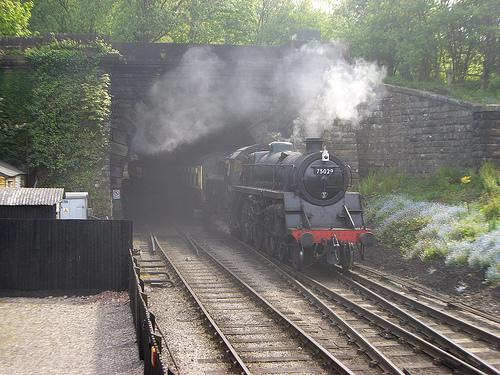Question: who is there?
Choices:
A. Everyone.
B. No one.
C. The father.
D. The family.
Answer with the letter. Answer: B Question: when was this?
Choices:
A. Nighttime.
B. Morning.
C. Daytime.
D. Dusk.
Answer with the letter. Answer: C Question: where is this scene?
Choices:
A. Bridge.
B. Railway.
C. Stadium.
D. Park.
Answer with the letter. Answer: B Question: what is the weather?
Choices:
A. Cloudy.
B. Sunny.
C. Snowing.
D. Raining.
Answer with the letter. Answer: B Question: what type of scene is this?
Choices:
A. Indoor.
B. Forest.
C. Outdoor.
D. Desert.
Answer with the letter. Answer: C 